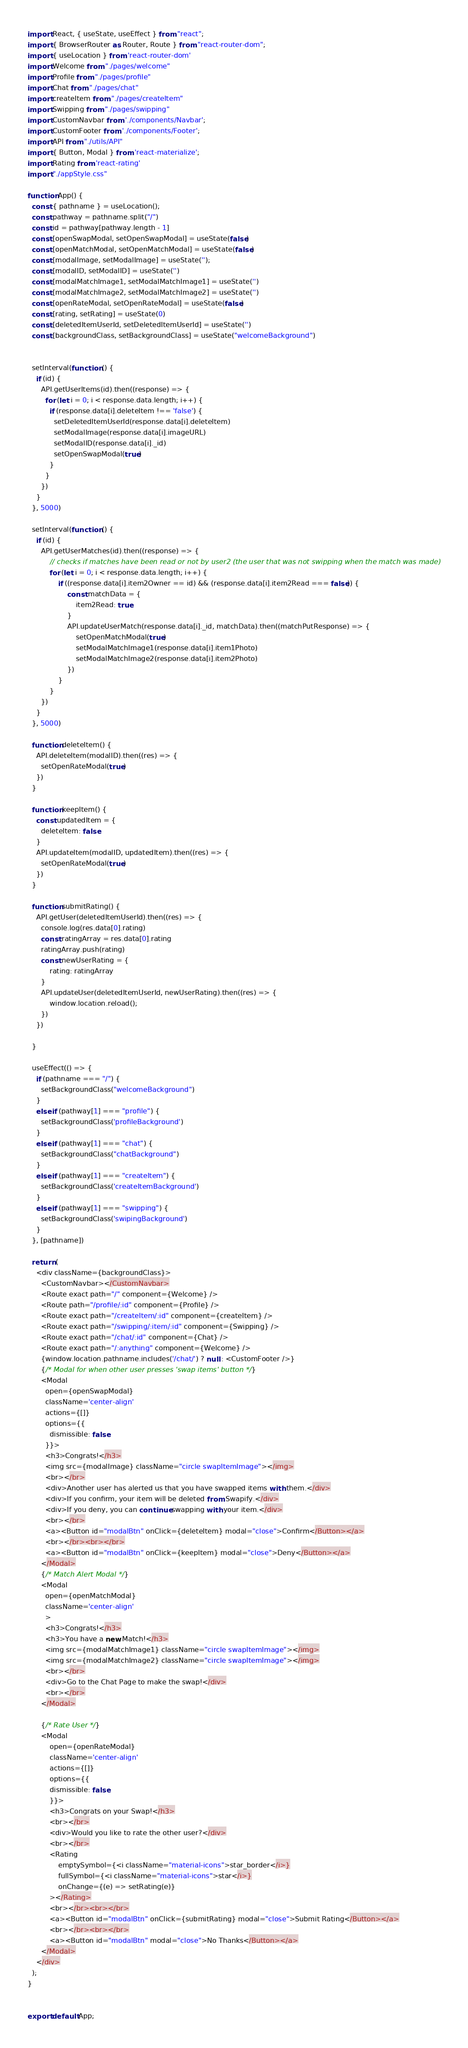<code> <loc_0><loc_0><loc_500><loc_500><_JavaScript_>import React, { useState, useEffect } from "react";
import { BrowserRouter as Router, Route } from "react-router-dom";
import { useLocation } from 'react-router-dom'
import Welcome from "./pages/welcome"
import Profile from "./pages/profile"
import Chat from "./pages/chat"
import createItem from "./pages/createItem"
import Swipping from "./pages/swipping"
import CustomNavbar from './components/Navbar';
import CustomFooter from './components/Footer';
import API from "./utils/API"
import { Button, Modal } from 'react-materialize';
import Rating from 'react-rating'
import "./appStyle.css"

function App() {
  const { pathname } = useLocation();
  const pathway = pathname.split("/")
  const id = pathway[pathway.length - 1]
  const [openSwapModal, setOpenSwapModal] = useState(false)
  const [openMatchModal, setOpenMatchModal] = useState(false)
  const [modalImage, setModalImage] = useState('');
  const [modalID, setModalID] = useState('')
  const [modalMatchImage1, setModalMatchImage1] = useState('')
  const [modalMatchImage2, setModalMatchImage2] = useState('')
  const [openRateModal, setOpenRateModal] = useState(false)
  const [rating, setRating] = useState(0)
  const [deletedItemUserId, setDeletedItemUserId] = useState('')
  const [backgroundClass, setBackgroundClass] = useState("welcomeBackground")
  
  
  setInterval(function () {
    if (id) {
      API.getUserItems(id).then((response) => {
        for (let i = 0; i < response.data.length; i++) {
          if (response.data[i].deleteItem !== 'false') {
            setDeletedItemUserId(response.data[i].deleteItem)
            setModalImage(response.data[i].imageURL)
            setModalID(response.data[i]._id)
            setOpenSwapModal(true)
          }
        }
      })
    }
  }, 5000)

  setInterval(function () {
    if (id) {
      API.getUserMatches(id).then((response) => {
          // checks if matches have been read or not by user2 (the user that was not swipping when the match was made)
          for (let i = 0; i < response.data.length; i++) {
              if ((response.data[i].item2Owner == id) && (response.data[i].item2Read === false)) {
                  const matchData = {
                      item2Read: true
                  }
                  API.updateUserMatch(response.data[i]._id, matchData).then((matchPutResponse) => {
                      setOpenMatchModal(true)
                      setModalMatchImage1(response.data[i].item1Photo)
                      setModalMatchImage2(response.data[i].item2Photo)
                  })
              }
          }
      })
    }
  }, 5000)

  function deleteItem() {
    API.deleteItem(modalID).then((res) => {
      setOpenRateModal(true)
    })
  }

  function keepItem() {
    const updatedItem = {
      deleteItem: false
    }
    API.updateItem(modalID, updatedItem).then((res) => {
      setOpenRateModal(true)
    })
  }

  function submitRating() {
    API.getUser(deletedItemUserId).then((res) => {
      console.log(res.data[0].rating)
      const ratingArray = res.data[0].rating
      ratingArray.push(rating)
      const newUserRating = {
          rating: ratingArray
      }
      API.updateUser(deletedItemUserId, newUserRating).then((res) => {
          window.location.reload();
      })
    })

  }

  useEffect(() => {
    if (pathname === "/") {
      setBackgroundClass("welcomeBackground")
    }
    else if (pathway[1] === "profile") {
      setBackgroundClass('profileBackground')
    }
    else if (pathway[1] === "chat") {
      setBackgroundClass("chatBackground")
    }
    else if (pathway[1] === "createItem") {
      setBackgroundClass('createItemBackground')
    }
    else if (pathway[1] === "swipping") {
      setBackgroundClass('swipingBackground')
    }
  }, [pathname])

  return (
    <div className={backgroundClass}>
      <CustomNavbar></CustomNavbar>
      <Route exact path="/" component={Welcome} />
      <Route path="/profile/:id" component={Profile} />
      <Route exact path="/createItem/:id" component={createItem} />
      <Route exact path="/swipping/:item/:id" component={Swipping} />
      <Route exact path="/chat/:id" component={Chat} />
      <Route exact path="/:anything" component={Welcome} />
      {window.location.pathname.includes('/chat/') ? null : <CustomFooter />}  
      {/* Modal for when other user presses 'swap items' button */}
      <Modal
        open={openSwapModal}
        className='center-align'
        actions={[]}
        options={{
          dismissible: false
        }}>
        <h3>Congrats!</h3>
        <img src={modalImage} className="circle swapItemImage"></img>
        <br></br>
        <div>Another user has alerted us that you have swapped items with them.</div>
        <div>If you confirm, your item will be deleted from Swapify.</div>
        <div>If you deny, you can continue swapping with your item.</div>
        <br></br>
        <a><Button id="modalBtn" onClick={deleteItem} modal="close">Confirm</Button></a>
        <br></br><br></br>
        <a><Button id="modalBtn" onClick={keepItem} modal="close">Deny</Button></a>
      </Modal>
      {/* Match Alert Modal */}
      <Modal
        open={openMatchModal}
        className='center-align'
        >
        <h3>Congrats!</h3>
        <h3>You have a new Match!</h3>
        <img src={modalMatchImage1} className="circle swapItemImage"></img>
        <img src={modalMatchImage2} className="circle swapItemImage"></img>
        <br></br>
        <div>Go to the Chat Page to make the swap!</div>
        <br></br>
      </Modal>

      {/* Rate User */}
      <Modal
          open={openRateModal}
          className='center-align'
          actions={[]}
          options={{
          dismissible: false
          }}>
          <h3>Congrats on your Swap!</h3>
          <br></br>
          <div>Would you like to rate the other user?</div>
          <br></br>
          <Rating
              emptySymbol={<i className="material-icons">star_border</i>}
              fullSymbol={<i className="material-icons">star</i>}
              onChange={(e) => setRating(e)}
          ></Rating>
          <br></br><br></br>
          <a><Button id="modalBtn" onClick={submitRating} modal="close">Submit Rating</Button></a>
          <br></br><br></br>
          <a><Button id="modalBtn" modal="close">No Thanks</Button></a>
      </Modal>
    </div>
  );
}


export default App;
</code> 